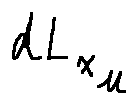Convert formula to latex. <formula><loc_0><loc_0><loc_500><loc_500>d L _ { x _ { \mu } }</formula> 